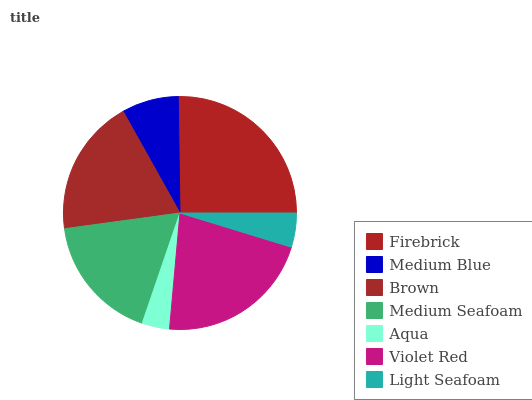Is Aqua the minimum?
Answer yes or no. Yes. Is Firebrick the maximum?
Answer yes or no. Yes. Is Medium Blue the minimum?
Answer yes or no. No. Is Medium Blue the maximum?
Answer yes or no. No. Is Firebrick greater than Medium Blue?
Answer yes or no. Yes. Is Medium Blue less than Firebrick?
Answer yes or no. Yes. Is Medium Blue greater than Firebrick?
Answer yes or no. No. Is Firebrick less than Medium Blue?
Answer yes or no. No. Is Medium Seafoam the high median?
Answer yes or no. Yes. Is Medium Seafoam the low median?
Answer yes or no. Yes. Is Medium Blue the high median?
Answer yes or no. No. Is Firebrick the low median?
Answer yes or no. No. 